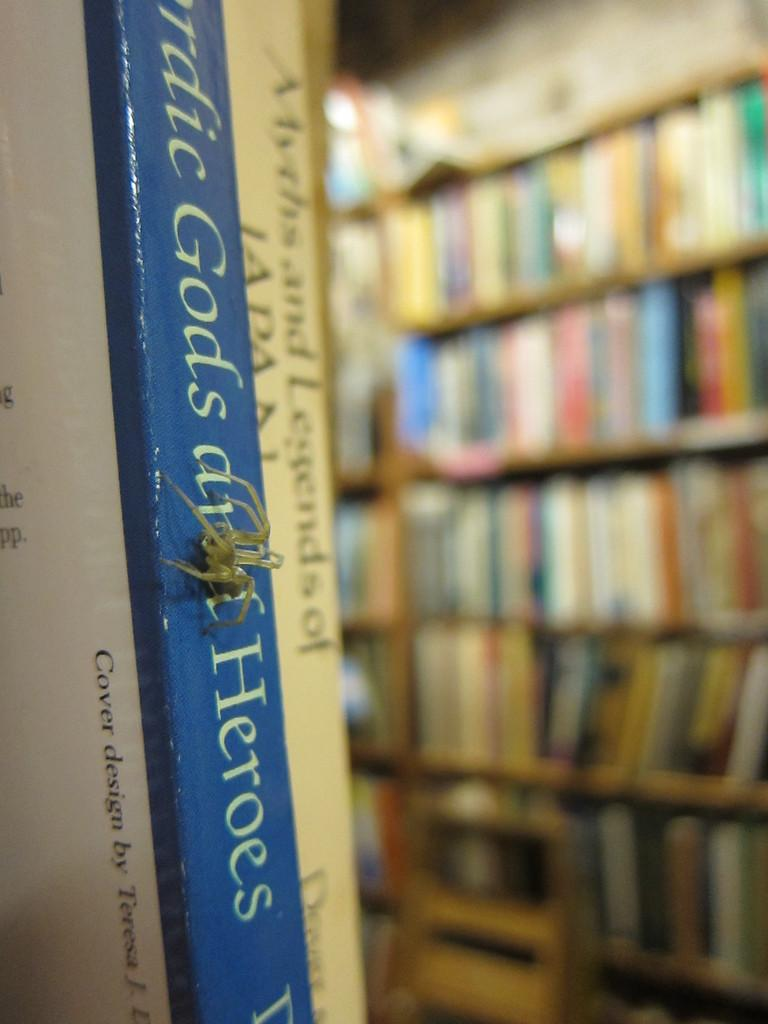<image>
Summarize the visual content of the image. a book with the word heroes on it 